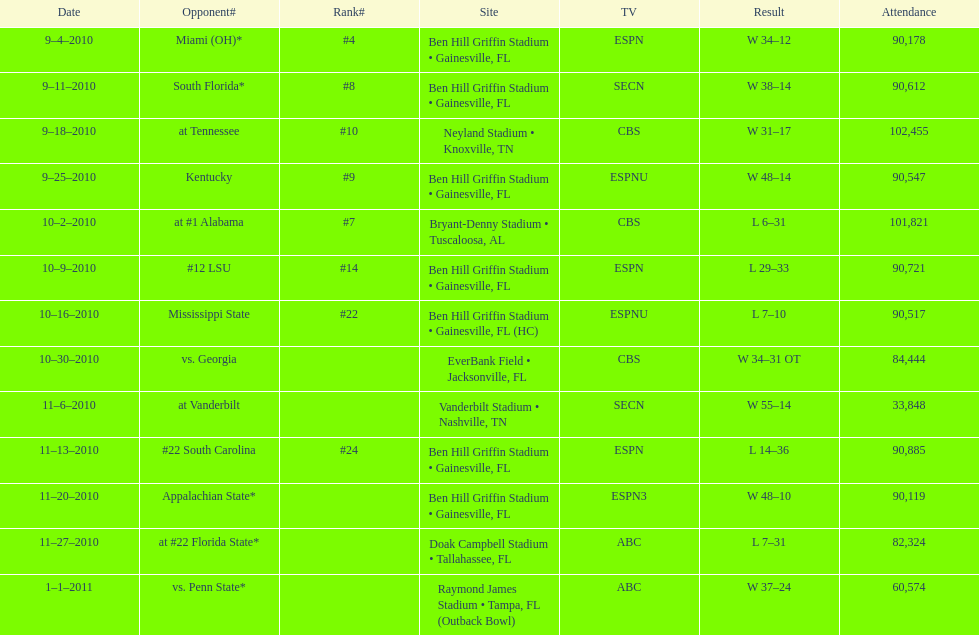What is the number of games won by the university of florida with a margin of at least 10 points? 7. 